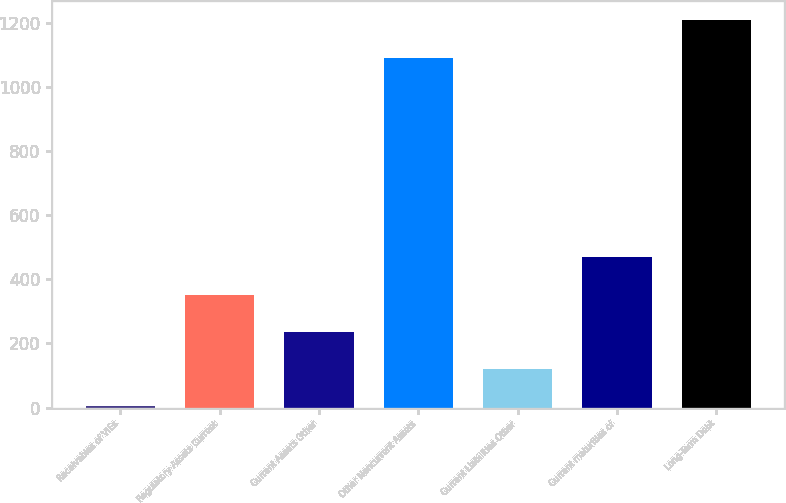<chart> <loc_0><loc_0><loc_500><loc_500><bar_chart><fcel>Receivables of VIEs<fcel>Regulatory Assets Current<fcel>Current Assets Other<fcel>Other Noncurrent Assets<fcel>Current Liabilities Other<fcel>Current maturities of<fcel>Long-Term Debt<nl><fcel>4<fcel>352<fcel>236<fcel>1091<fcel>120<fcel>468<fcel>1207<nl></chart> 